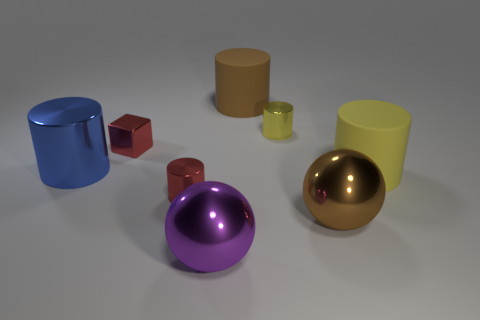Is there anything else that is the same shape as the blue thing?
Offer a very short reply. Yes. What number of things are either tiny cubes or metallic spheres?
Your answer should be very brief. 3. What size is the yellow rubber thing that is the same shape as the big brown rubber object?
Your response must be concise. Large. Is there any other thing that is the same size as the yellow matte thing?
Your answer should be very brief. Yes. What number of other objects are there of the same color as the large shiny cylinder?
Provide a succinct answer. 0. What number of cylinders are either purple objects or big metal objects?
Give a very brief answer. 1. What is the color of the big object that is on the left side of the thing that is in front of the brown metal ball?
Provide a short and direct response. Blue. What is the shape of the yellow shiny thing?
Your response must be concise. Cylinder. Does the metal ball left of the brown matte cylinder have the same size as the large yellow matte object?
Keep it short and to the point. Yes. Is there a small cylinder that has the same material as the red block?
Provide a succinct answer. Yes. 